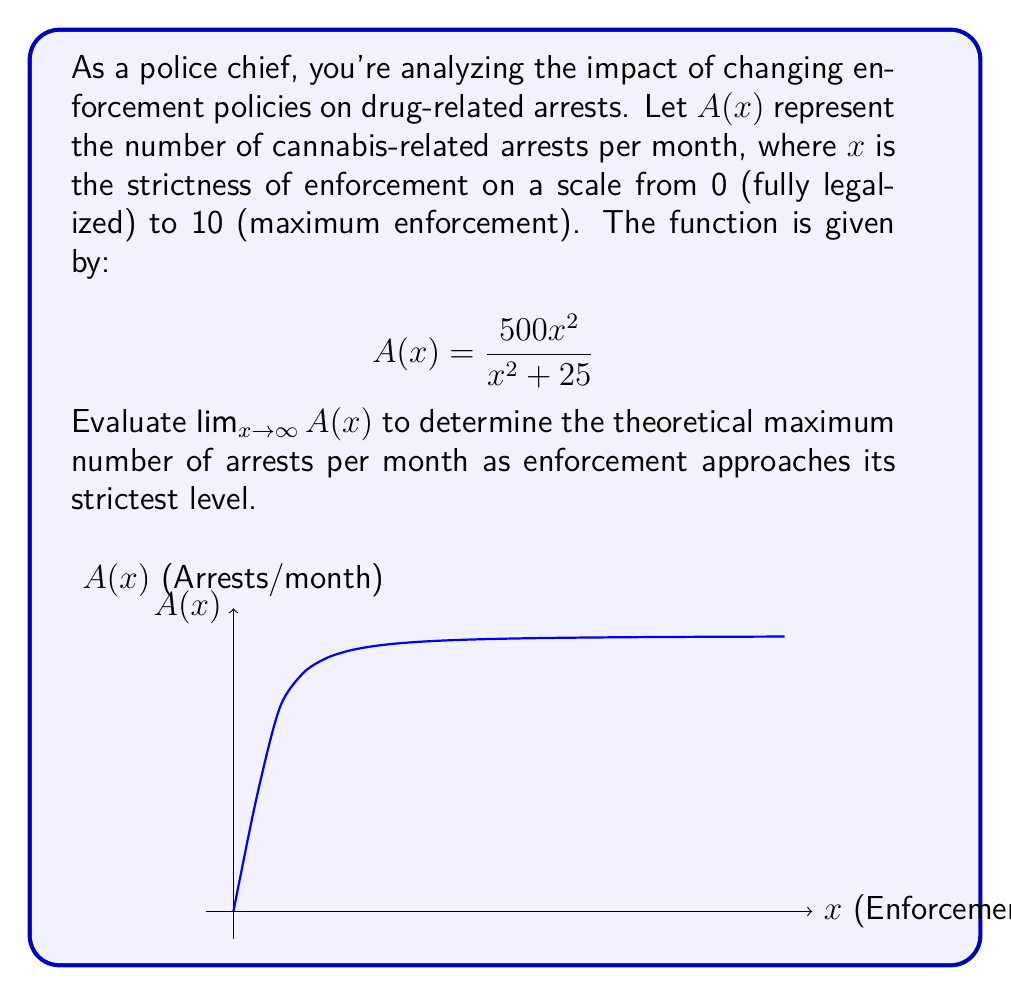Help me with this question. To evaluate $\lim_{x \to \infty} A(x)$, we'll follow these steps:

1) First, let's examine the function:
   $$A(x) = \frac{500x^2}{x^2 + 25}$$

2) As $x$ approaches infinity, both the numerator and denominator will grow large. We can use the method of dividing by the highest power of $x$ in the denominator:

   $$\lim_{x \to \infty} A(x) = \lim_{x \to \infty} \frac{500x^2}{x^2 + 25}$$

3) Divide both numerator and denominator by $x^2$:

   $$\lim_{x \to \infty} \frac{500x^2/x^2}{(x^2 + 25)/x^2} = \lim_{x \to \infty} \frac{500}{1 + 25/x^2}$$

4) As $x$ approaches infinity, $25/x^2$ approaches 0:

   $$\lim_{x \to \infty} \frac{500}{1 + 25/x^2} = \frac{500}{1 + 0} = 500$$

Therefore, as enforcement approaches its strictest level, the number of arrests per month approaches a maximum of 500.
Answer: $500$ arrests/month 